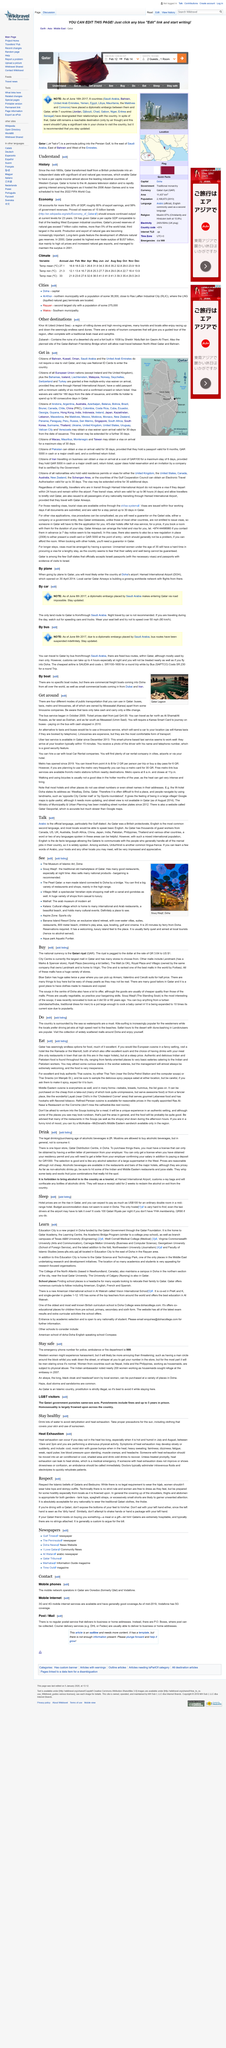Outline some significant characteristics in this image. In 2006, Qatar hosted the prestigious Asian Games, which is one of the most significant multi-sport events in the Asia-Pacific region. Qatar transformed itself from a British protectorate into an independent state, becoming a part of its history. Qatar is the place that is home to the Al Jazeera television station. 